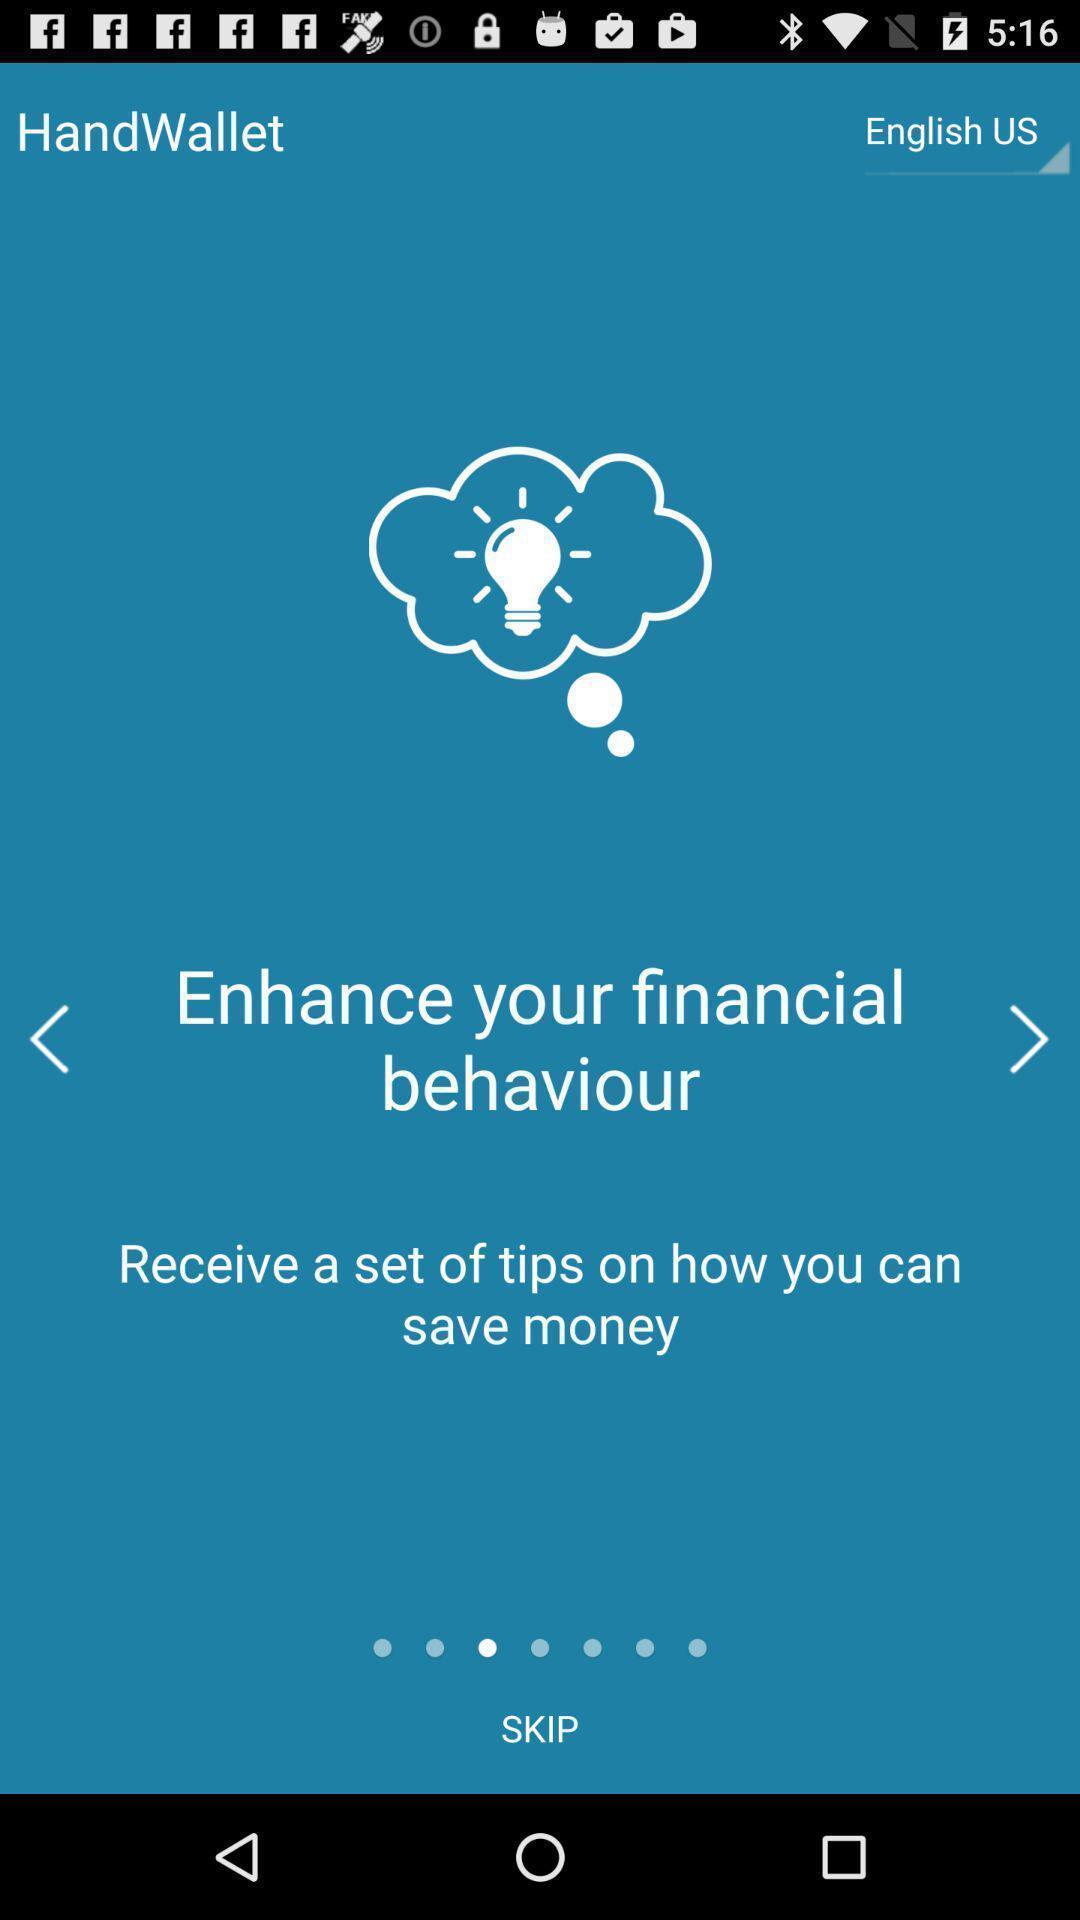Explain what's happening in this screen capture. Start page of a management app. 